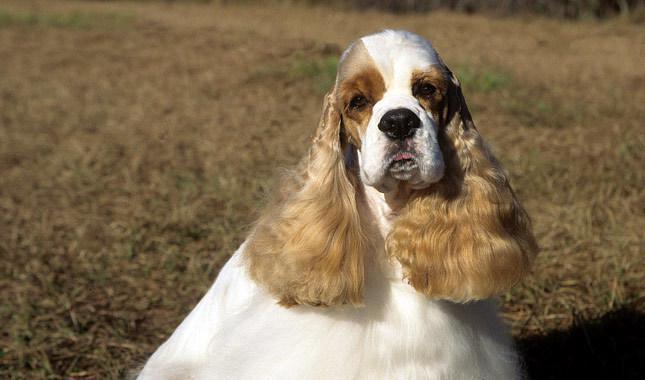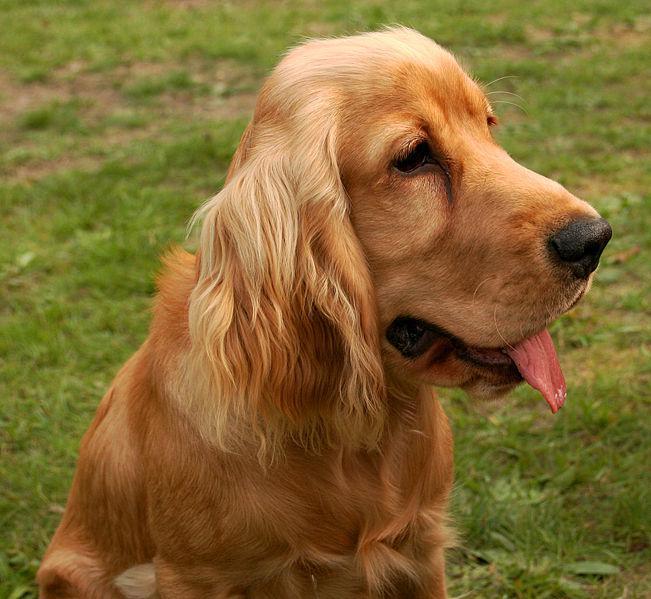The first image is the image on the left, the second image is the image on the right. Evaluate the accuracy of this statement regarding the images: "the dog in the image on the left is lying down". Is it true? Answer yes or no. No. The first image is the image on the left, the second image is the image on the right. Assess this claim about the two images: "One cocker spaniel is not pictured in an outdoor setting.". Correct or not? Answer yes or no. No. The first image is the image on the left, the second image is the image on the right. Considering the images on both sides, is "There is at least one extended dog tongue in one of the images." valid? Answer yes or no. Yes. The first image is the image on the left, the second image is the image on the right. Considering the images on both sides, is "The dog in the image on the left is looking toward the camera." valid? Answer yes or no. Yes. 